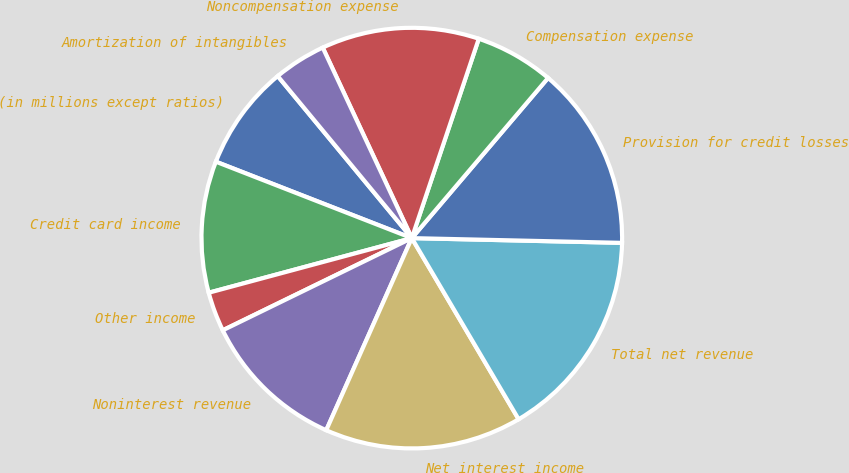Convert chart. <chart><loc_0><loc_0><loc_500><loc_500><pie_chart><fcel>(in millions except ratios)<fcel>Credit card income<fcel>Other income<fcel>Noninterest revenue<fcel>Net interest income<fcel>Total net revenue<fcel>Provision for credit losses<fcel>Compensation expense<fcel>Noncompensation expense<fcel>Amortization of intangibles<nl><fcel>8.08%<fcel>10.1%<fcel>3.04%<fcel>11.11%<fcel>15.15%<fcel>16.16%<fcel>14.14%<fcel>6.06%<fcel>12.12%<fcel>4.04%<nl></chart> 